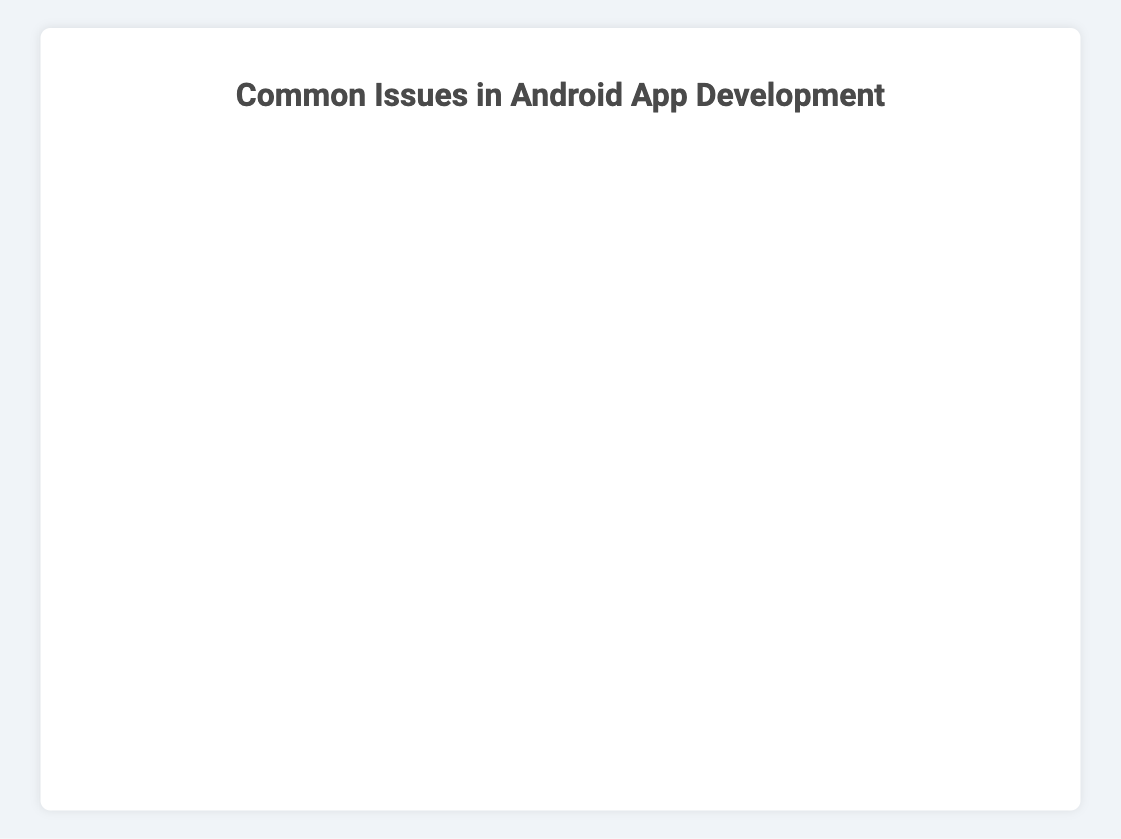What issue has the highest occurrence of Compilation Errors? Looking at the bar chart, observe which issue has the longest red section corresponding to Compilation Errors. For "Debugging and Troubleshooting," the red segment is longest, representing 40%.
Answer: Debugging and Troubleshooting Which issue has a greater percentage of Performance Issues than Query Optimization? Identify the percentage values for both Performance Issues under "Debugging and Troubleshooting" (10%) and Query Optimization under "Database Management" (35%) to compare.
Answer: Database Management How do the Styling Issues in UI Design compare to Tag Reading in NFC Technology? Locate the sections of the bar chart for "User Interface (UI) Design" and "NFC Technology." Styling Issues make up 35% and Tag Reading for NFC Technology constitutes 30%. Therefore, Styling Issues are slightly higher.
Answer: Styling Issues are higher What is the total percentage of components alignment and responsiveness issues in UI Design? Add the percentages for both components, which are 25% for Component Alignment and 15% for Responsiveness, summing up to: 25 + 15 = 40%.
Answer: 40% What issue has the lowest percentage of Security Vulnerabilities? Find the bar representing Security Vulnerabilities and compare its length across all issues. "Permissions and Security" shows this category with a 15% segment, which is the lowest among issues.
Answer: Permissions and Security Compare the percentage of Data Interference in NFC Technology to Store Submission in App Deployment. Which is higher? Locate the percentages for Data Interference (25%) in "NFC Technology" and Store Submission (35%) in "App Deployment". Store Submission is higher.
Answer: Store Submission Which issue has the highest combined percentage for Authentication Errors and API Changes in API Integration? Sum the percentage values for Authentication Errors (20%) and API Changes (25%) in "API Integration": 20 + 25 = 45%. No other combination within API Integration exceeds this.
Answer: 45% How does the occurrence of Logic Errors in Debugging and Troubleshooting compare to Data Encryption in Permissions and Security? Identify the bar sections representing Logic Errors (20%) and Data Encryption (35%). Data Encryption is notably higher.
Answer: Data Encryption is higher Which issue category among NFC Technology has equal percentages for more than one problem? Check the bar chart for the "NFC Technology" issue. Both Tag Writing and Data Interference show equal proportions of 25%.
Answer: Tag Writing and Data Interference Compare the occurrence of Component Alignment in UI Design with Unit Testing in Code Quality. Look at "User Interface (UI) Design" for Component Alignment (25%) and "Code Quality and Maintainability" for Unit Testing (15%). Component Alignment has a higher percentage.
Answer: Component Alignment is higher 